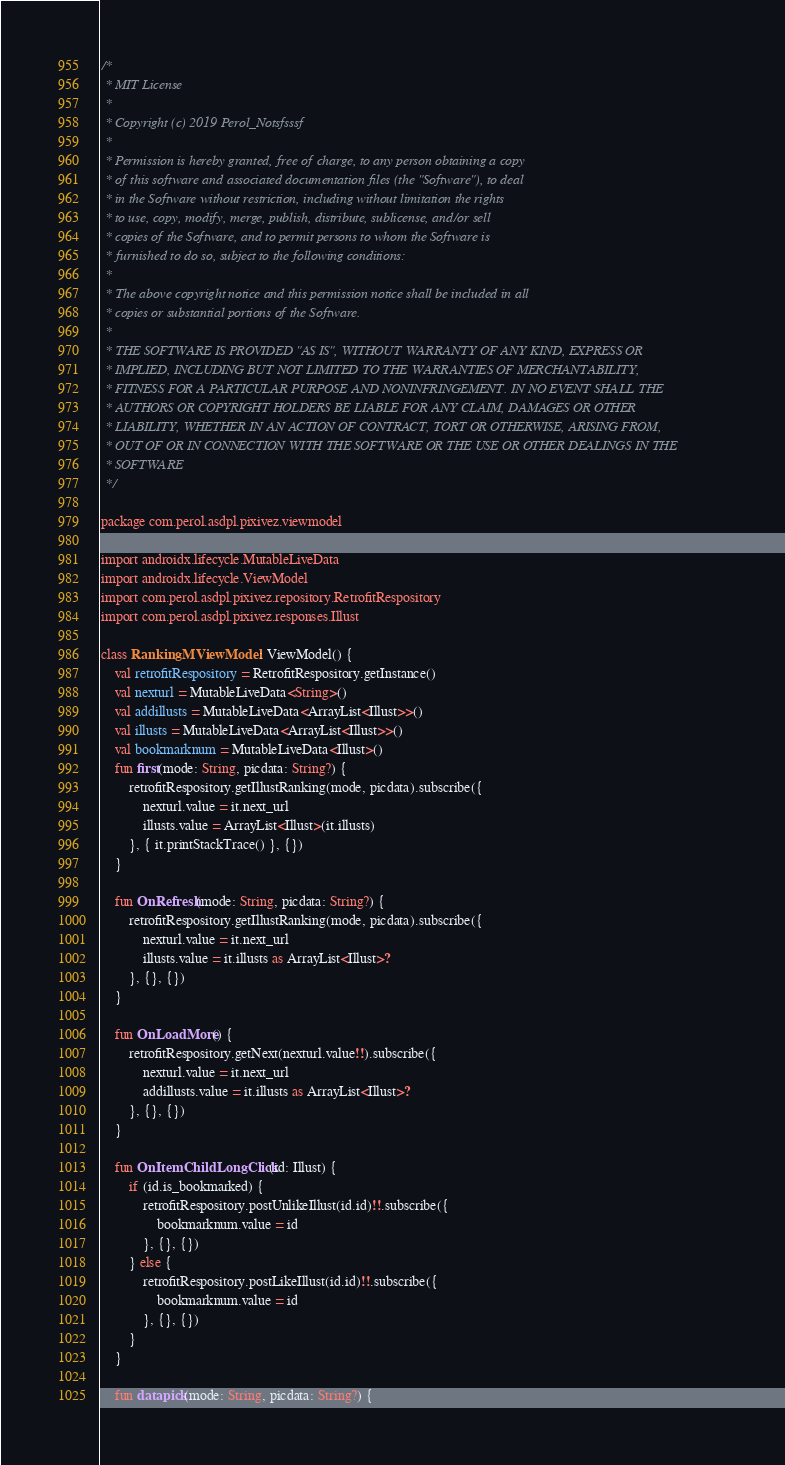<code> <loc_0><loc_0><loc_500><loc_500><_Kotlin_>/*
 * MIT License
 *
 * Copyright (c) 2019 Perol_Notsfsssf
 *
 * Permission is hereby granted, free of charge, to any person obtaining a copy
 * of this software and associated documentation files (the "Software"), to deal
 * in the Software without restriction, including without limitation the rights
 * to use, copy, modify, merge, publish, distribute, sublicense, and/or sell
 * copies of the Software, and to permit persons to whom the Software is
 * furnished to do so, subject to the following conditions:
 *
 * The above copyright notice and this permission notice shall be included in all
 * copies or substantial portions of the Software.
 *
 * THE SOFTWARE IS PROVIDED "AS IS", WITHOUT WARRANTY OF ANY KIND, EXPRESS OR
 * IMPLIED, INCLUDING BUT NOT LIMITED TO THE WARRANTIES OF MERCHANTABILITY,
 * FITNESS FOR A PARTICULAR PURPOSE AND NONINFRINGEMENT. IN NO EVENT SHALL THE
 * AUTHORS OR COPYRIGHT HOLDERS BE LIABLE FOR ANY CLAIM, DAMAGES OR OTHER
 * LIABILITY, WHETHER IN AN ACTION OF CONTRACT, TORT OR OTHERWISE, ARISING FROM,
 * OUT OF OR IN CONNECTION WITH THE SOFTWARE OR THE USE OR OTHER DEALINGS IN THE
 * SOFTWARE
 */

package com.perol.asdpl.pixivez.viewmodel

import androidx.lifecycle.MutableLiveData
import androidx.lifecycle.ViewModel
import com.perol.asdpl.pixivez.repository.RetrofitRespository
import com.perol.asdpl.pixivez.responses.Illust

class RankingMViewModel : ViewModel() {
    val retrofitRespository = RetrofitRespository.getInstance()
    val nexturl = MutableLiveData<String>()
    val addillusts = MutableLiveData<ArrayList<Illust>>()
    val illusts = MutableLiveData<ArrayList<Illust>>()
    val bookmarknum = MutableLiveData<Illust>()
    fun first(mode: String, picdata: String?) {
        retrofitRespository.getIllustRanking(mode, picdata).subscribe({
            nexturl.value = it.next_url
            illusts.value = ArrayList<Illust>(it.illusts)
        }, { it.printStackTrace() }, {})
    }

    fun OnRefresh(mode: String, picdata: String?) {
        retrofitRespository.getIllustRanking(mode, picdata).subscribe({
            nexturl.value = it.next_url
            illusts.value = it.illusts as ArrayList<Illust>?
        }, {}, {})
    }

    fun OnLoadMore() {
        retrofitRespository.getNext(nexturl.value!!).subscribe({
            nexturl.value = it.next_url
            addillusts.value = it.illusts as ArrayList<Illust>?
        }, {}, {})
    }

    fun OnItemChildLongClick(id: Illust) {
        if (id.is_bookmarked) {
            retrofitRespository.postUnlikeIllust(id.id)!!.subscribe({
                bookmarknum.value = id
            }, {}, {})
        } else {
            retrofitRespository.postLikeIllust(id.id)!!.subscribe({
                bookmarknum.value = id
            }, {}, {})
        }
    }

    fun datapick(mode: String, picdata: String?) {</code> 